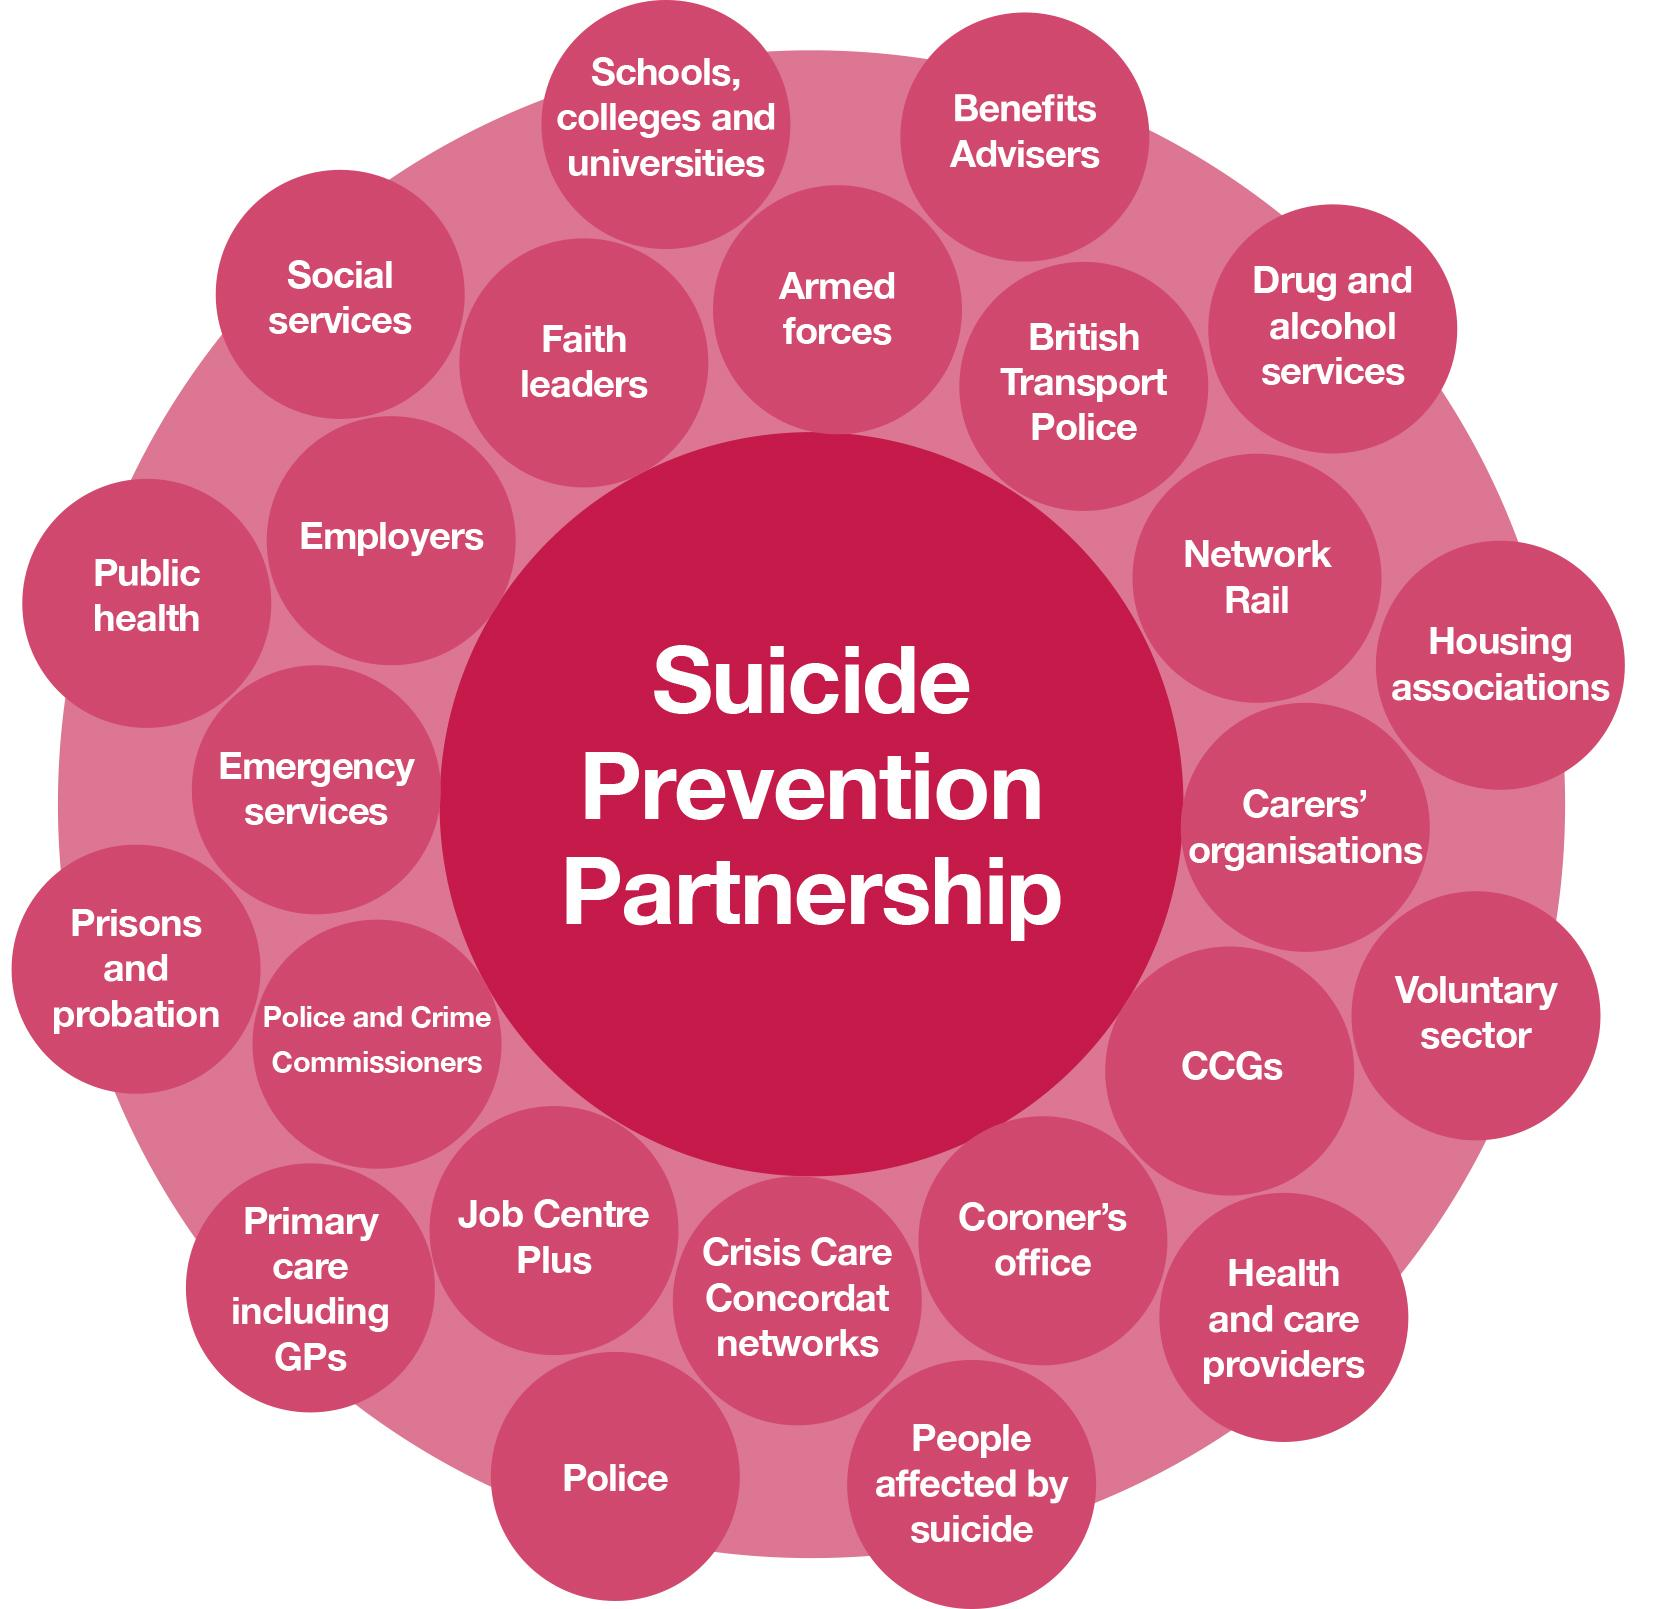Point out several critical features in this image. The center circle contains the written message 'Suicide Prevention Partnership.' The word "police" appears three times in the image. 